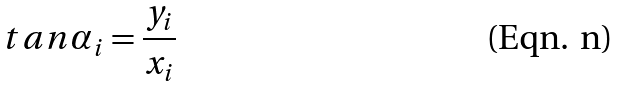<formula> <loc_0><loc_0><loc_500><loc_500>t a n \alpha _ { i } = \frac { y _ { i } } { x _ { i } }</formula> 